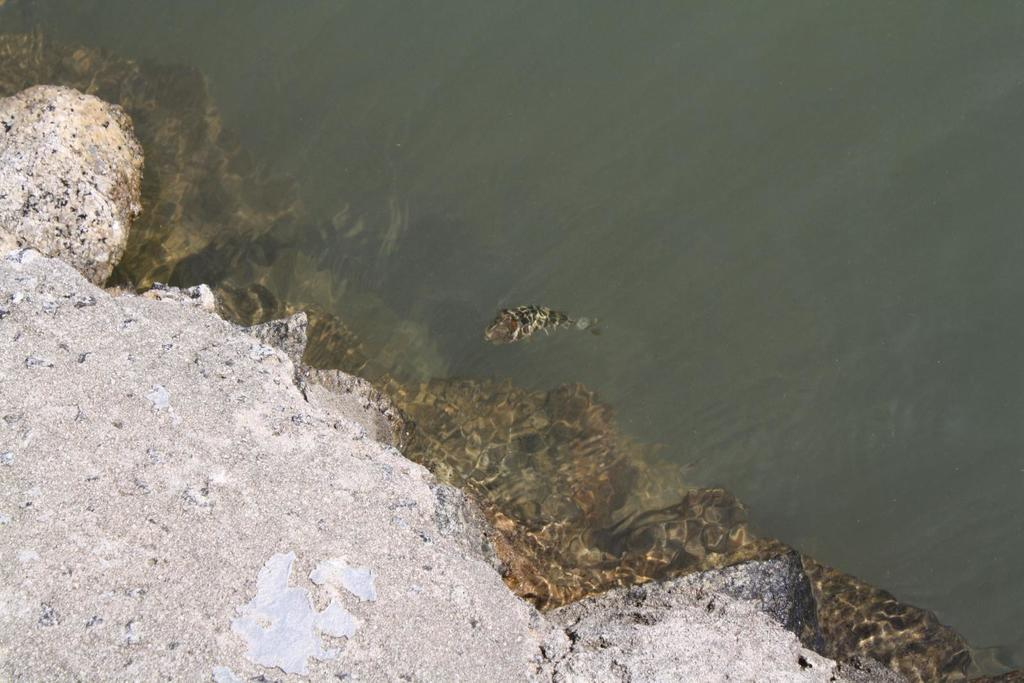What type of natural elements can be seen in the image? There are rocks in the image. What kind of aquatic creature is present in the image? There is a fish in the water in the image. Can you see your aunt's elbow in the image? There is no reference to an aunt or an elbow in the image; it features rocks and a fish in the water. 